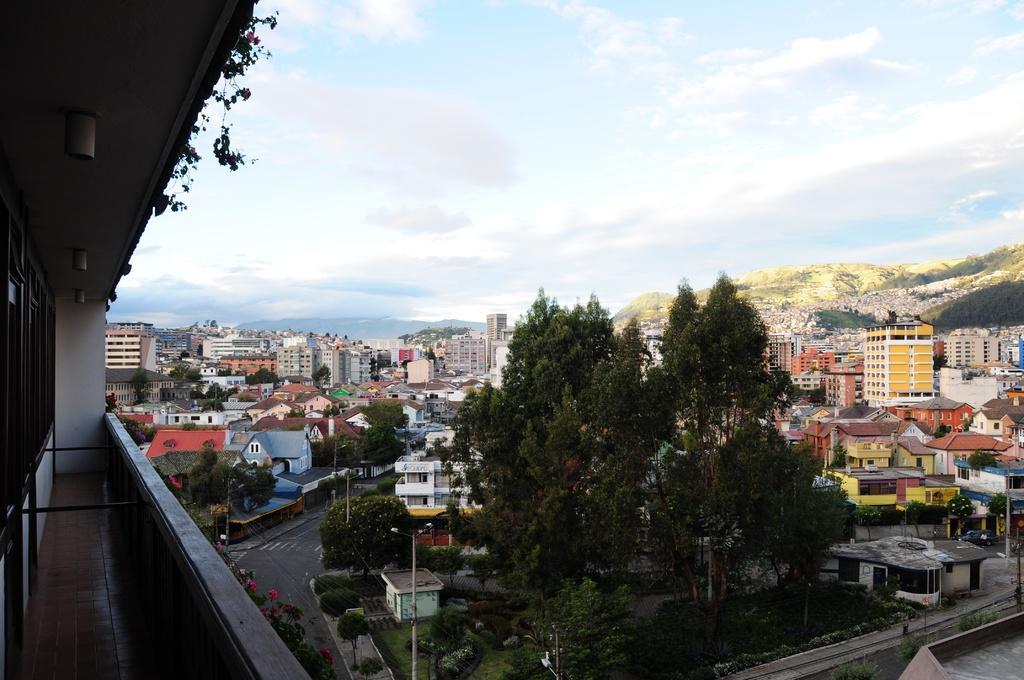In one or two sentences, can you explain what this image depicts? In this image I can see the building. To the side of the building I can see the pink color flowers to the plant and the road. To the sides of the road I can see the poles, many trees and the buildings. In the background I can see few more buildings, mountains, clouds and the sky. 